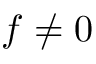Convert formula to latex. <formula><loc_0><loc_0><loc_500><loc_500>f \neq 0</formula> 